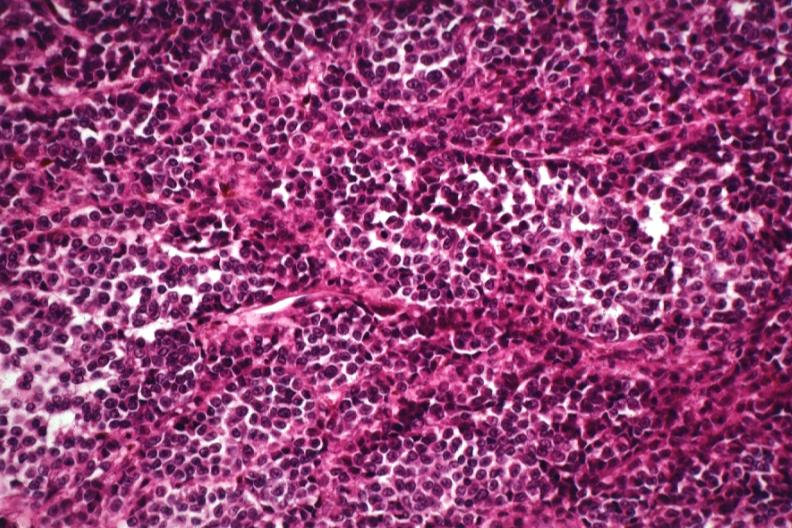where is this?
Answer the question using a single word or phrase. Skin 